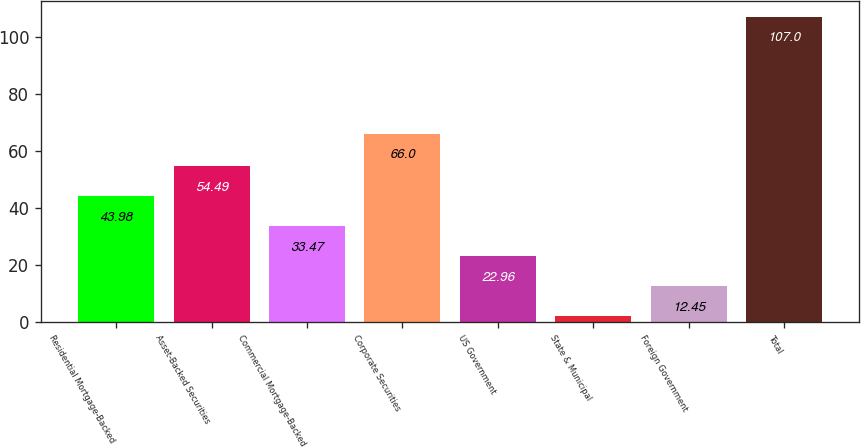Convert chart. <chart><loc_0><loc_0><loc_500><loc_500><bar_chart><fcel>Residential Mortgage-Backed<fcel>Asset-Backed Securities<fcel>Commercial Mortgage-Backed<fcel>Corporate Securities<fcel>US Government<fcel>State & Municipal<fcel>Foreign Government<fcel>Total<nl><fcel>43.98<fcel>54.49<fcel>33.47<fcel>66<fcel>22.96<fcel>1.94<fcel>12.45<fcel>107<nl></chart> 